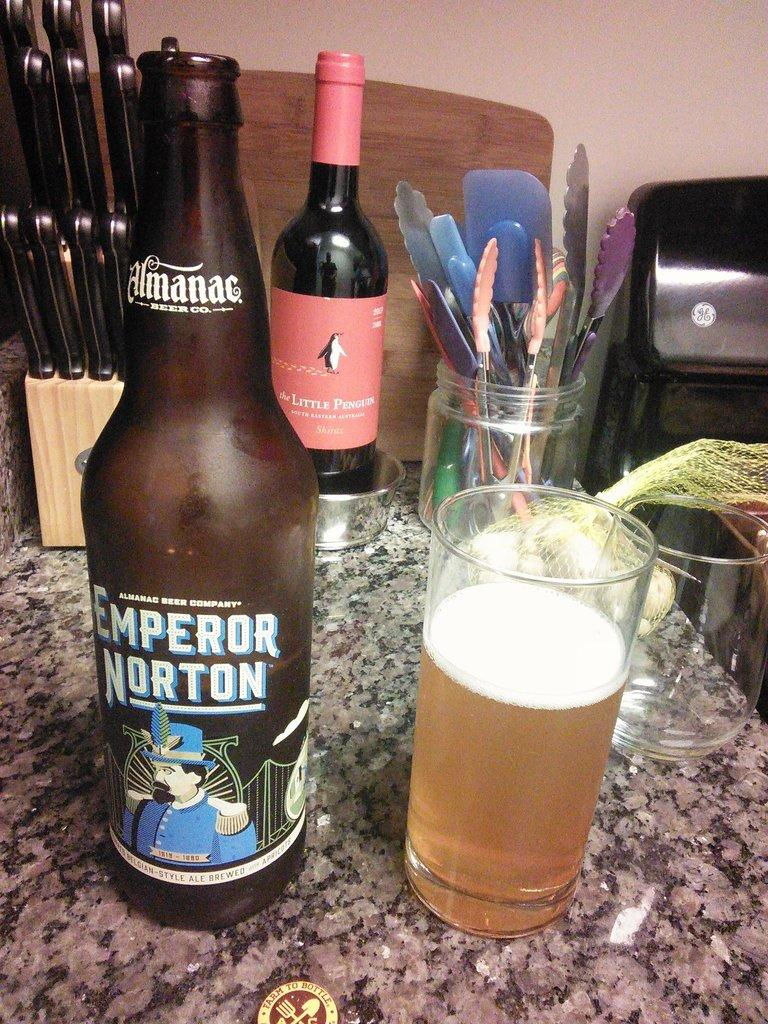<image>
Create a compact narrative representing the image presented. Bottle of beer that says Emperor Norton on it. 